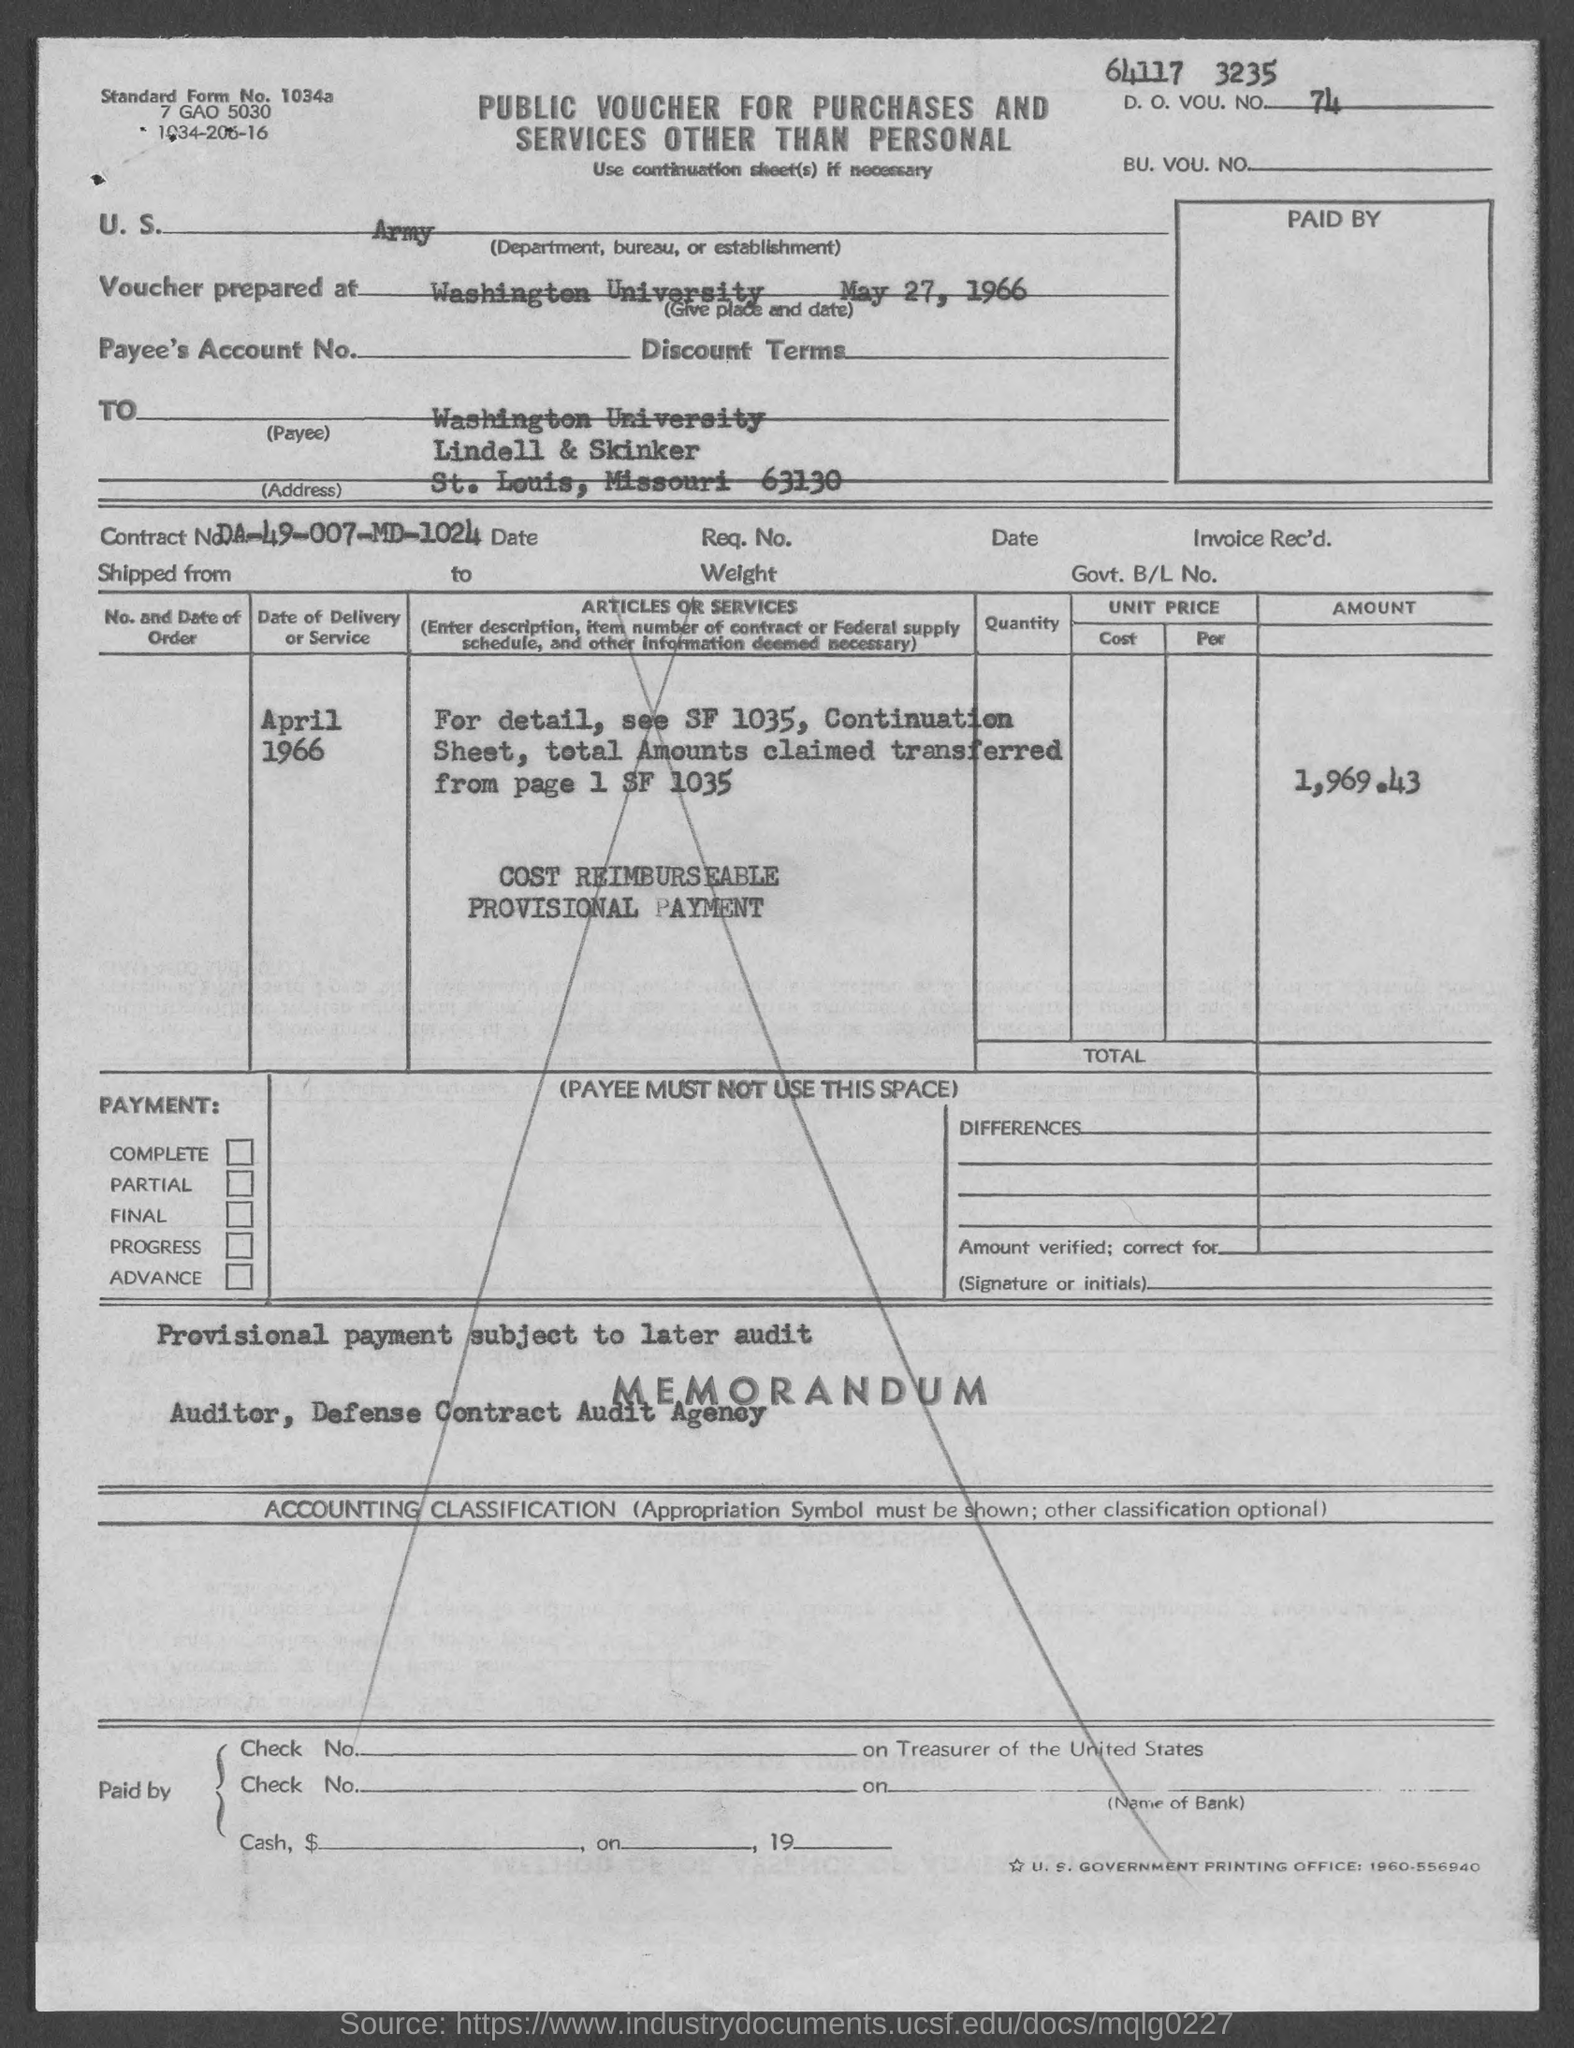What is the D. O. VOU. NO.?
Make the answer very short. 74. The voucher is prepared at?
Keep it short and to the point. Washington University. 